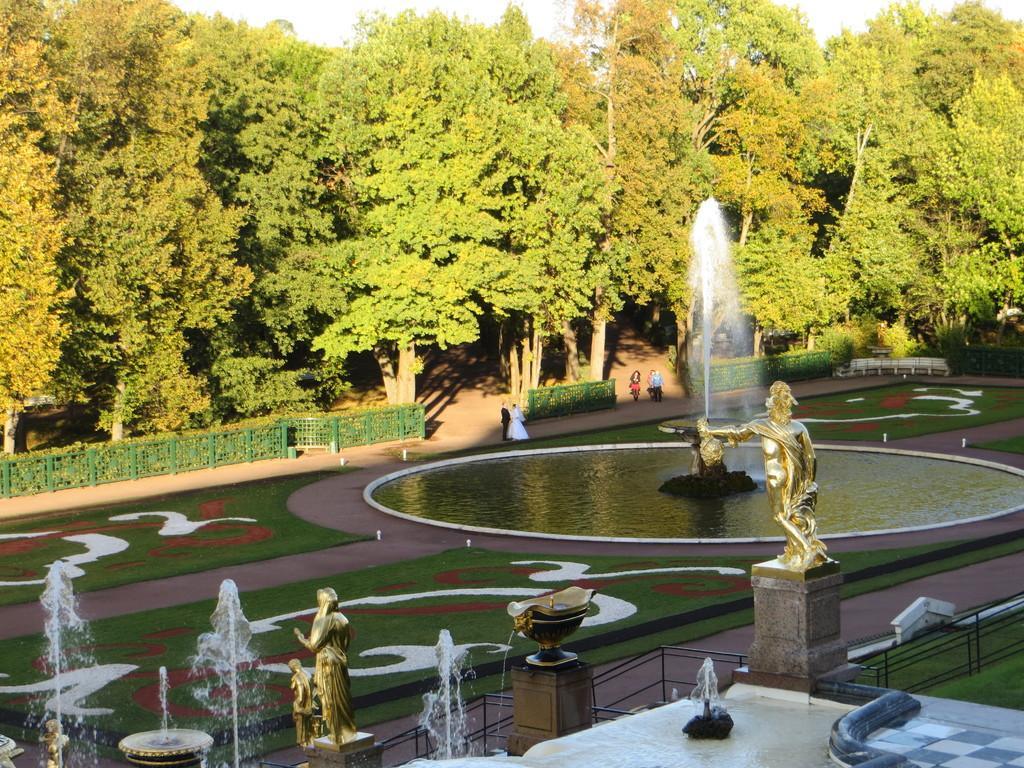Can you describe this image briefly? These are the trees with branches and leaves. This looks like a fence. I can see few people standing. These are the sculptures, which are gold in color. I can see a water fountain with the water flowing. This is the grass. 